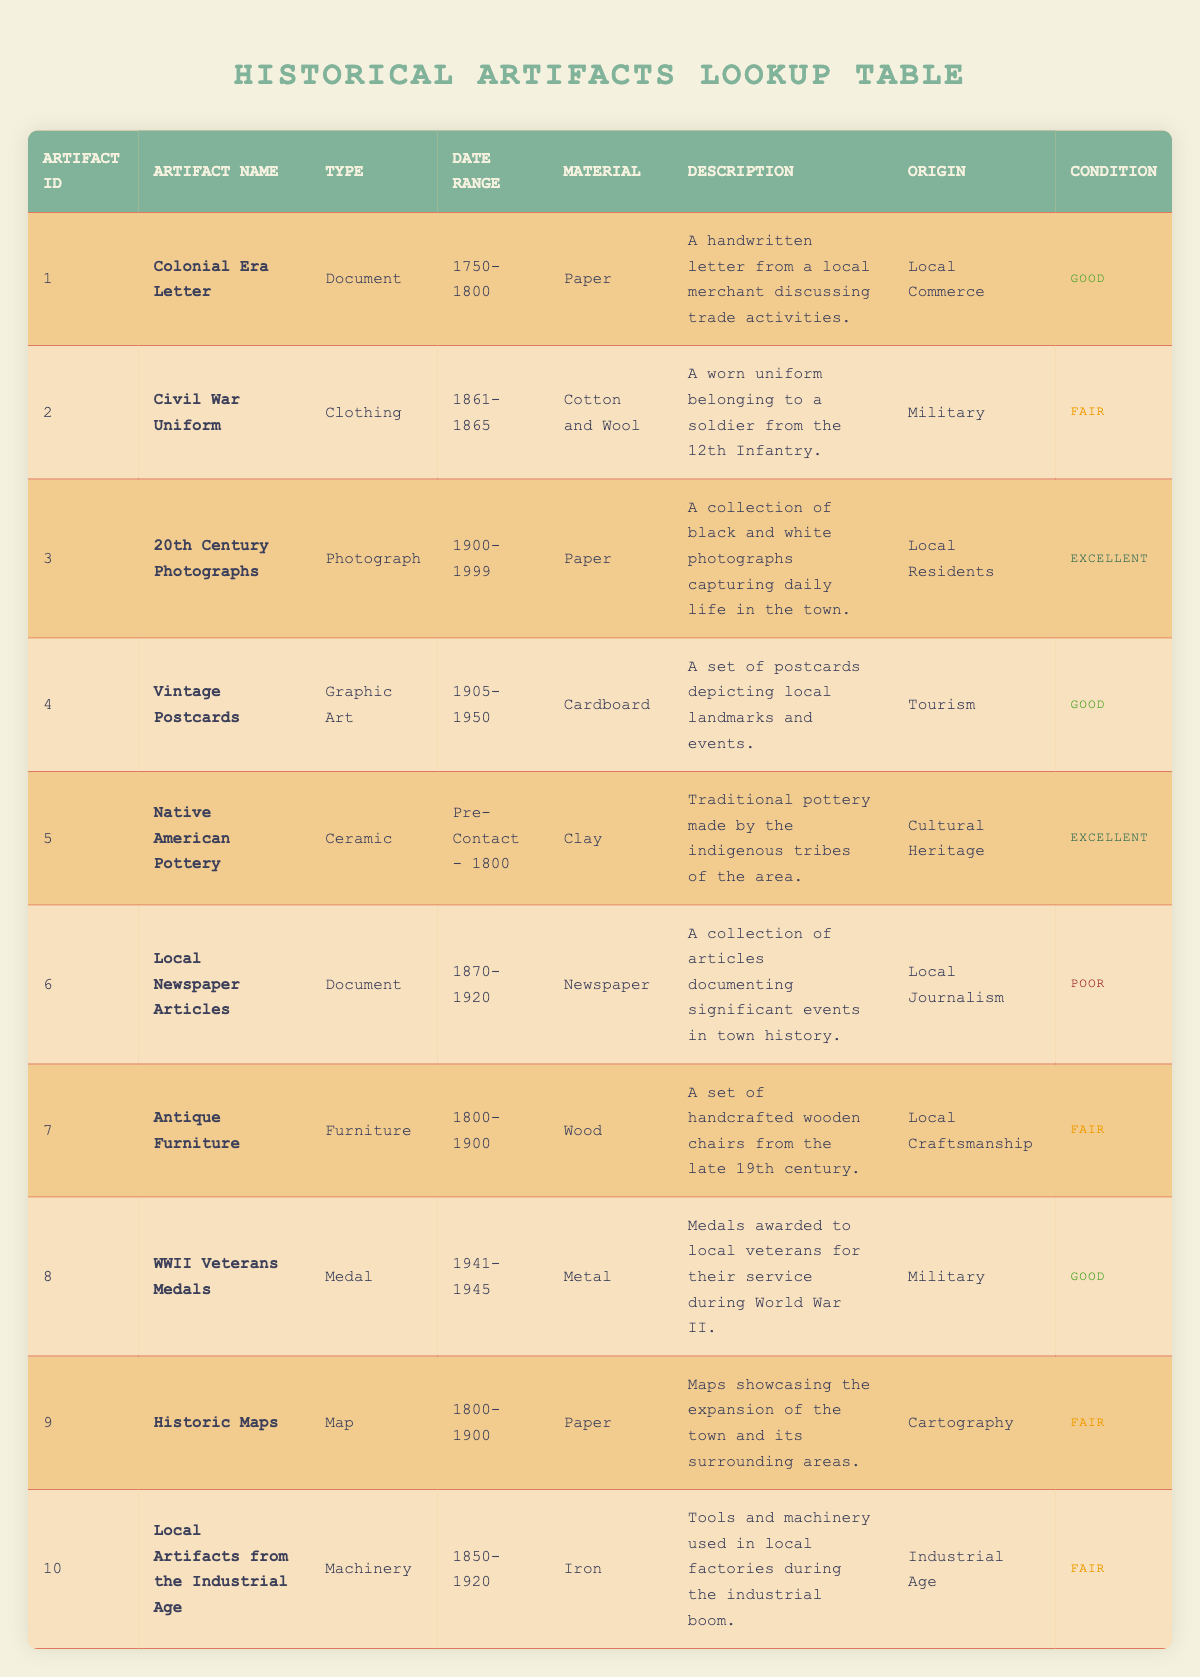What is the artifact type of the "Native American Pottery"? The table lists each artifact along with its type. Looking at the row for "Native American Pottery," the specified artifact type is noted as "Ceramic."
Answer: Ceramic How many artifacts are listed as being in "Excellent" condition? To find this, we examine the table for the condition column and count all entries marked as "Excellent." There are two artifacts: "20th Century Photographs" and "Native American Pottery."
Answer: 2 What material is the "Civil War Uniform" made from? The row corresponding to the "Civil War Uniform" indicates that it is made from "Cotton and Wool." Therefore, we can directly retrieve this information from the material column of that row.
Answer: Cotton and Wool Is there a "Document" artifact listed as being in "Poor" condition? By checking the condition of the artifacts in the document category, we see that "Local Newspaper Articles" is classified as in "Poor" condition. Thus, the answer to this question is affirmative.
Answer: Yes Which artifact from the table has the oldest date range? The artifact with the oldest date range is "Native American Pottery," which dates from "Pre-Contact - 1800." We can determine this by comparing the date ranges of all the artifacts presented in the table and selecting the one that starts the earliest.
Answer: Native American Pottery How many unique artifact types are there in total? By examining the types column for distinct entries, we find the types: Document, Clothing, Photograph, Graphic Art, Ceramic, Furniture, Medal, Map, and Machinery, making a total of 9 unique types.
Answer: 9 What is the condition of the "WWII Veterans Medals"? The row for "WWII Veterans Medals" indicates the condition as "Good." This information can be found directly in the condition column of that specific row.
Answer: Good How many artifacts belong to the "Military" origin category? We analyze the origin column and discover that two artifacts—"Civil War Uniform" and "WWII Veterans Medals"—belong to the "Military" category. Adding these gives us a total of 2 artifacts.
Answer: 2 Which artifact is listed as the oldest based on the date range? To determine the artifact with the oldest date range, we evaluate the date ranges of all artifacts. The "Native American Pottery" with the range "Pre-Contact - 1800" represents the earliest period, establishing it as the oldest artifact in this list.
Answer: Native American Pottery 